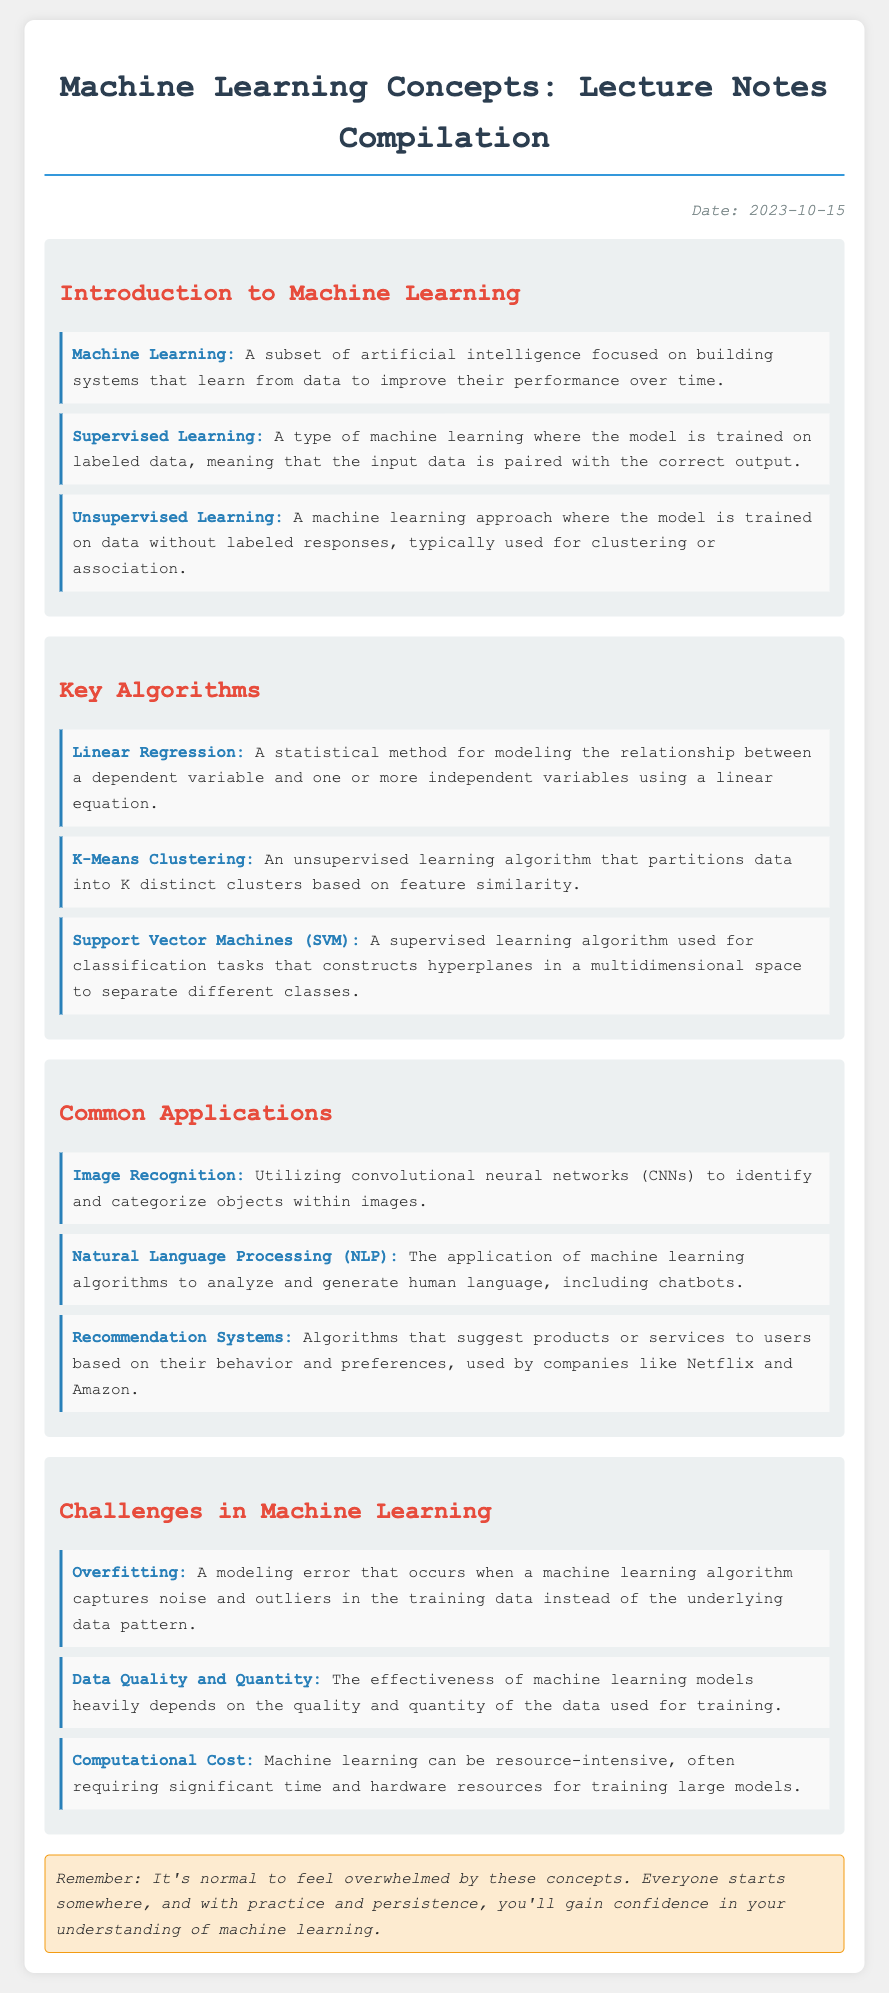What is the date of the lecture notes? The document specifies that the date of the lecture notes is provided in the date section.
Answer: 2023-10-15 What is the definition of Machine Learning? The document includes a definition of Machine Learning in the Introduction section.
Answer: A subset of artificial intelligence focused on building systems that learn from data to improve their performance over time Which algorithm is used for classification tasks? The document lists examples of algorithms, including one specified for classification tasks.
Answer: Support Vector Machines (SVM) What is one common application of Natural Language Processing? The document mentions applications of NLP, which includes certain functions as examples.
Answer: Analyzing and generating human language What is one challenge in machine learning related to data? The document discusses challenges in machine learning, one of which relates to data quality and quantity.
Answer: Data Quality and Quantity What does Overfitting refer to? The document describes Overfitting in the Challenges section, outlining its meaning.
Answer: A modeling error that occurs when a machine learning algorithm captures noise and outliers in the training data instead of the underlying data pattern What is an example of a supervised learning method? The document defines and categorizes different learning methods, naming a specific example.
Answer: Supervised Learning What is the color of the heading for the "Key Algorithms" section? The document uses a certain color coding for headings in each section, including this one.
Answer: Red What specific note is included for those experiencing imposter syndrome? The document provides an explicitly noted remark aimed at individuals struggling with feelings of inadequacy.
Answer: It's normal to feel overwhelmed by these concepts 